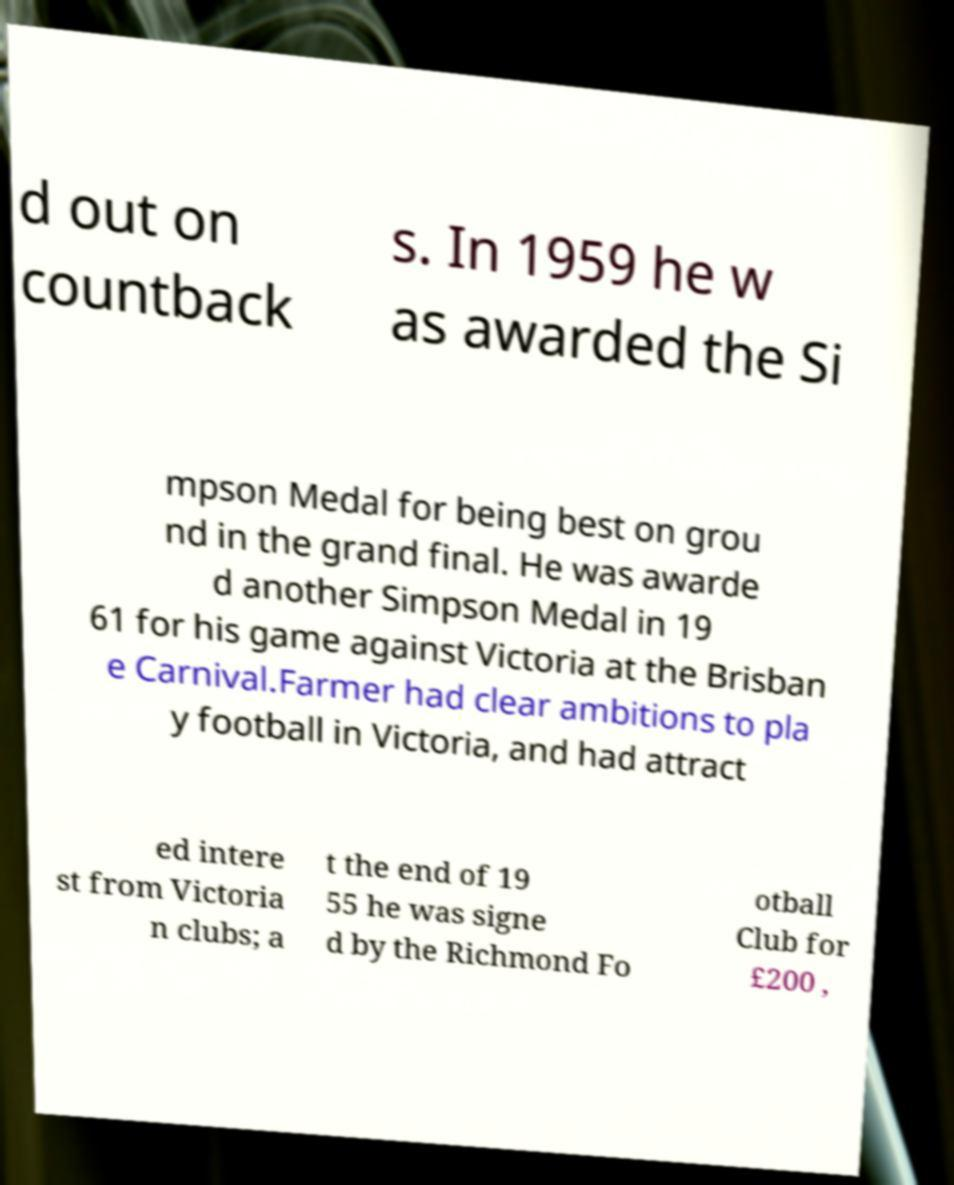Can you read and provide the text displayed in the image?This photo seems to have some interesting text. Can you extract and type it out for me? d out on countback s. In 1959 he w as awarded the Si mpson Medal for being best on grou nd in the grand final. He was awarde d another Simpson Medal in 19 61 for his game against Victoria at the Brisban e Carnival.Farmer had clear ambitions to pla y football in Victoria, and had attract ed intere st from Victoria n clubs; a t the end of 19 55 he was signe d by the Richmond Fo otball Club for £200 , 